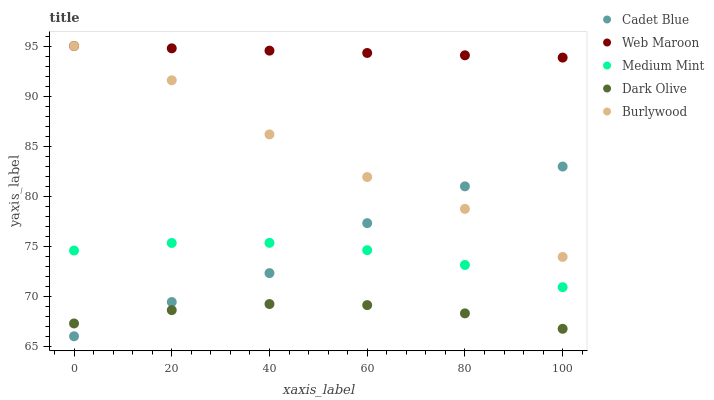Does Dark Olive have the minimum area under the curve?
Answer yes or no. Yes. Does Web Maroon have the maximum area under the curve?
Answer yes or no. Yes. Does Burlywood have the minimum area under the curve?
Answer yes or no. No. Does Burlywood have the maximum area under the curve?
Answer yes or no. No. Is Web Maroon the smoothest?
Answer yes or no. Yes. Is Burlywood the roughest?
Answer yes or no. Yes. Is Dark Olive the smoothest?
Answer yes or no. No. Is Dark Olive the roughest?
Answer yes or no. No. Does Cadet Blue have the lowest value?
Answer yes or no. Yes. Does Burlywood have the lowest value?
Answer yes or no. No. Does Web Maroon have the highest value?
Answer yes or no. Yes. Does Dark Olive have the highest value?
Answer yes or no. No. Is Medium Mint less than Web Maroon?
Answer yes or no. Yes. Is Web Maroon greater than Medium Mint?
Answer yes or no. Yes. Does Medium Mint intersect Cadet Blue?
Answer yes or no. Yes. Is Medium Mint less than Cadet Blue?
Answer yes or no. No. Is Medium Mint greater than Cadet Blue?
Answer yes or no. No. Does Medium Mint intersect Web Maroon?
Answer yes or no. No. 